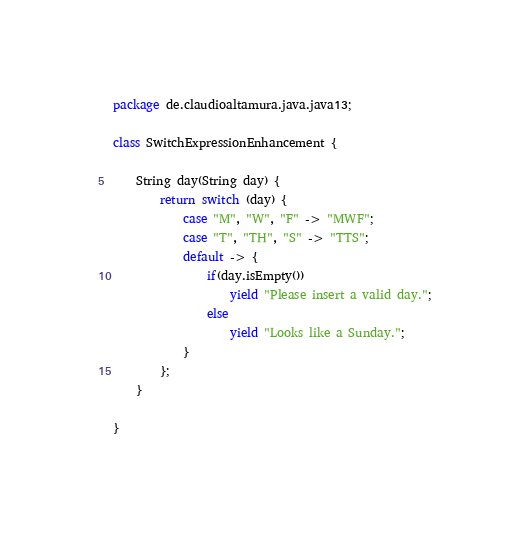Convert code to text. <code><loc_0><loc_0><loc_500><loc_500><_Java_>package de.claudioaltamura.java.java13;

class SwitchExpressionEnhancement {

	String day(String day) {
		return switch (day) {
			case "M", "W", "F" -> "MWF";
			case "T", "TH", "S" -> "TTS";
			default -> {
				if(day.isEmpty())
					yield "Please insert a valid day.";
                else
					yield "Looks like a Sunday.";
			}
		};
	}

}</code> 